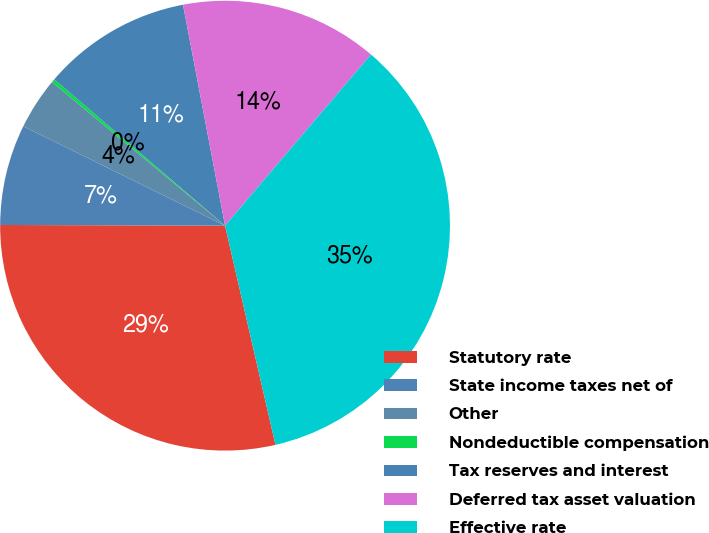Convert chart. <chart><loc_0><loc_0><loc_500><loc_500><pie_chart><fcel>Statutory rate<fcel>State income taxes net of<fcel>Other<fcel>Nondeductible compensation<fcel>Tax reserves and interest<fcel>Deferred tax asset valuation<fcel>Effective rate<nl><fcel>28.65%<fcel>7.24%<fcel>3.74%<fcel>0.25%<fcel>10.73%<fcel>14.23%<fcel>35.17%<nl></chart> 